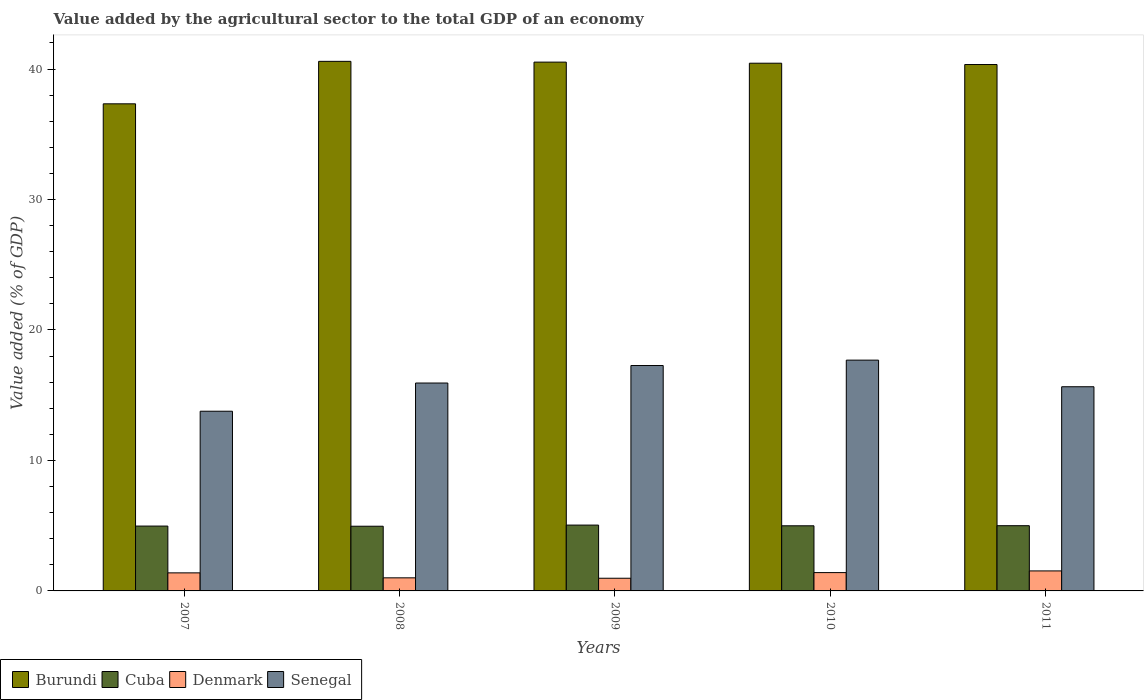How many groups of bars are there?
Give a very brief answer. 5. Are the number of bars per tick equal to the number of legend labels?
Ensure brevity in your answer.  Yes. How many bars are there on the 5th tick from the left?
Your response must be concise. 4. How many bars are there on the 3rd tick from the right?
Your response must be concise. 4. In how many cases, is the number of bars for a given year not equal to the number of legend labels?
Keep it short and to the point. 0. What is the value added by the agricultural sector to the total GDP in Denmark in 2010?
Your answer should be very brief. 1.4. Across all years, what is the maximum value added by the agricultural sector to the total GDP in Senegal?
Give a very brief answer. 17.69. Across all years, what is the minimum value added by the agricultural sector to the total GDP in Denmark?
Provide a short and direct response. 0.97. In which year was the value added by the agricultural sector to the total GDP in Burundi maximum?
Offer a terse response. 2008. What is the total value added by the agricultural sector to the total GDP in Cuba in the graph?
Your response must be concise. 24.97. What is the difference between the value added by the agricultural sector to the total GDP in Denmark in 2009 and that in 2011?
Your answer should be compact. -0.56. What is the difference between the value added by the agricultural sector to the total GDP in Burundi in 2007 and the value added by the agricultural sector to the total GDP in Denmark in 2011?
Provide a succinct answer. 35.8. What is the average value added by the agricultural sector to the total GDP in Senegal per year?
Give a very brief answer. 16.07. In the year 2010, what is the difference between the value added by the agricultural sector to the total GDP in Senegal and value added by the agricultural sector to the total GDP in Cuba?
Your answer should be very brief. 12.7. What is the ratio of the value added by the agricultural sector to the total GDP in Burundi in 2007 to that in 2011?
Your answer should be very brief. 0.93. Is the difference between the value added by the agricultural sector to the total GDP in Senegal in 2007 and 2011 greater than the difference between the value added by the agricultural sector to the total GDP in Cuba in 2007 and 2011?
Ensure brevity in your answer.  No. What is the difference between the highest and the second highest value added by the agricultural sector to the total GDP in Denmark?
Keep it short and to the point. 0.13. What is the difference between the highest and the lowest value added by the agricultural sector to the total GDP in Denmark?
Ensure brevity in your answer.  0.56. In how many years, is the value added by the agricultural sector to the total GDP in Cuba greater than the average value added by the agricultural sector to the total GDP in Cuba taken over all years?
Your answer should be very brief. 2. Is the sum of the value added by the agricultural sector to the total GDP in Burundi in 2009 and 2011 greater than the maximum value added by the agricultural sector to the total GDP in Denmark across all years?
Make the answer very short. Yes. Is it the case that in every year, the sum of the value added by the agricultural sector to the total GDP in Denmark and value added by the agricultural sector to the total GDP in Burundi is greater than the sum of value added by the agricultural sector to the total GDP in Cuba and value added by the agricultural sector to the total GDP in Senegal?
Offer a very short reply. Yes. What does the 2nd bar from the right in 2011 represents?
Offer a terse response. Denmark. Is it the case that in every year, the sum of the value added by the agricultural sector to the total GDP in Senegal and value added by the agricultural sector to the total GDP in Denmark is greater than the value added by the agricultural sector to the total GDP in Cuba?
Provide a succinct answer. Yes. How many years are there in the graph?
Make the answer very short. 5. What is the difference between two consecutive major ticks on the Y-axis?
Provide a succinct answer. 10. Does the graph contain any zero values?
Offer a very short reply. No. Does the graph contain grids?
Your answer should be very brief. No. How many legend labels are there?
Offer a very short reply. 4. What is the title of the graph?
Keep it short and to the point. Value added by the agricultural sector to the total GDP of an economy. What is the label or title of the Y-axis?
Offer a very short reply. Value added (% of GDP). What is the Value added (% of GDP) of Burundi in 2007?
Offer a terse response. 37.34. What is the Value added (% of GDP) in Cuba in 2007?
Keep it short and to the point. 4.97. What is the Value added (% of GDP) in Denmark in 2007?
Make the answer very short. 1.38. What is the Value added (% of GDP) in Senegal in 2007?
Give a very brief answer. 13.77. What is the Value added (% of GDP) in Burundi in 2008?
Give a very brief answer. 40.59. What is the Value added (% of GDP) of Cuba in 2008?
Your answer should be compact. 4.96. What is the Value added (% of GDP) in Denmark in 2008?
Ensure brevity in your answer.  1. What is the Value added (% of GDP) of Senegal in 2008?
Offer a terse response. 15.94. What is the Value added (% of GDP) of Burundi in 2009?
Offer a terse response. 40.53. What is the Value added (% of GDP) of Cuba in 2009?
Provide a short and direct response. 5.05. What is the Value added (% of GDP) in Denmark in 2009?
Make the answer very short. 0.97. What is the Value added (% of GDP) in Senegal in 2009?
Your answer should be compact. 17.28. What is the Value added (% of GDP) in Burundi in 2010?
Keep it short and to the point. 40.45. What is the Value added (% of GDP) in Cuba in 2010?
Provide a short and direct response. 4.99. What is the Value added (% of GDP) of Denmark in 2010?
Provide a succinct answer. 1.4. What is the Value added (% of GDP) of Senegal in 2010?
Ensure brevity in your answer.  17.69. What is the Value added (% of GDP) of Burundi in 2011?
Your answer should be very brief. 40.35. What is the Value added (% of GDP) in Cuba in 2011?
Provide a short and direct response. 5. What is the Value added (% of GDP) of Denmark in 2011?
Ensure brevity in your answer.  1.53. What is the Value added (% of GDP) in Senegal in 2011?
Offer a very short reply. 15.65. Across all years, what is the maximum Value added (% of GDP) of Burundi?
Your response must be concise. 40.59. Across all years, what is the maximum Value added (% of GDP) of Cuba?
Keep it short and to the point. 5.05. Across all years, what is the maximum Value added (% of GDP) in Denmark?
Your response must be concise. 1.53. Across all years, what is the maximum Value added (% of GDP) of Senegal?
Offer a very short reply. 17.69. Across all years, what is the minimum Value added (% of GDP) in Burundi?
Give a very brief answer. 37.34. Across all years, what is the minimum Value added (% of GDP) of Cuba?
Your response must be concise. 4.96. Across all years, what is the minimum Value added (% of GDP) in Denmark?
Keep it short and to the point. 0.97. Across all years, what is the minimum Value added (% of GDP) in Senegal?
Make the answer very short. 13.77. What is the total Value added (% of GDP) of Burundi in the graph?
Make the answer very short. 199.26. What is the total Value added (% of GDP) in Cuba in the graph?
Provide a succinct answer. 24.97. What is the total Value added (% of GDP) of Denmark in the graph?
Keep it short and to the point. 6.3. What is the total Value added (% of GDP) in Senegal in the graph?
Provide a succinct answer. 80.33. What is the difference between the Value added (% of GDP) in Burundi in 2007 and that in 2008?
Give a very brief answer. -3.25. What is the difference between the Value added (% of GDP) of Cuba in 2007 and that in 2008?
Your answer should be very brief. 0.01. What is the difference between the Value added (% of GDP) of Denmark in 2007 and that in 2008?
Your answer should be very brief. 0.38. What is the difference between the Value added (% of GDP) of Senegal in 2007 and that in 2008?
Your answer should be very brief. -2.16. What is the difference between the Value added (% of GDP) in Burundi in 2007 and that in 2009?
Provide a short and direct response. -3.2. What is the difference between the Value added (% of GDP) in Cuba in 2007 and that in 2009?
Make the answer very short. -0.08. What is the difference between the Value added (% of GDP) of Denmark in 2007 and that in 2009?
Provide a succinct answer. 0.41. What is the difference between the Value added (% of GDP) of Senegal in 2007 and that in 2009?
Your response must be concise. -3.5. What is the difference between the Value added (% of GDP) of Burundi in 2007 and that in 2010?
Your answer should be compact. -3.11. What is the difference between the Value added (% of GDP) of Cuba in 2007 and that in 2010?
Your response must be concise. -0.02. What is the difference between the Value added (% of GDP) of Denmark in 2007 and that in 2010?
Provide a short and direct response. -0.02. What is the difference between the Value added (% of GDP) in Senegal in 2007 and that in 2010?
Provide a short and direct response. -3.92. What is the difference between the Value added (% of GDP) in Burundi in 2007 and that in 2011?
Your answer should be very brief. -3.01. What is the difference between the Value added (% of GDP) of Cuba in 2007 and that in 2011?
Your response must be concise. -0.03. What is the difference between the Value added (% of GDP) in Denmark in 2007 and that in 2011?
Ensure brevity in your answer.  -0.15. What is the difference between the Value added (% of GDP) of Senegal in 2007 and that in 2011?
Keep it short and to the point. -1.88. What is the difference between the Value added (% of GDP) of Burundi in 2008 and that in 2009?
Provide a short and direct response. 0.06. What is the difference between the Value added (% of GDP) of Cuba in 2008 and that in 2009?
Your answer should be compact. -0.09. What is the difference between the Value added (% of GDP) in Denmark in 2008 and that in 2009?
Your answer should be very brief. 0.03. What is the difference between the Value added (% of GDP) of Senegal in 2008 and that in 2009?
Provide a short and direct response. -1.34. What is the difference between the Value added (% of GDP) of Burundi in 2008 and that in 2010?
Your answer should be compact. 0.14. What is the difference between the Value added (% of GDP) in Cuba in 2008 and that in 2010?
Ensure brevity in your answer.  -0.03. What is the difference between the Value added (% of GDP) in Denmark in 2008 and that in 2010?
Ensure brevity in your answer.  -0.4. What is the difference between the Value added (% of GDP) in Senegal in 2008 and that in 2010?
Ensure brevity in your answer.  -1.75. What is the difference between the Value added (% of GDP) of Burundi in 2008 and that in 2011?
Your answer should be very brief. 0.24. What is the difference between the Value added (% of GDP) of Cuba in 2008 and that in 2011?
Give a very brief answer. -0.04. What is the difference between the Value added (% of GDP) of Denmark in 2008 and that in 2011?
Give a very brief answer. -0.53. What is the difference between the Value added (% of GDP) of Senegal in 2008 and that in 2011?
Your answer should be very brief. 0.28. What is the difference between the Value added (% of GDP) of Burundi in 2009 and that in 2010?
Give a very brief answer. 0.08. What is the difference between the Value added (% of GDP) in Cuba in 2009 and that in 2010?
Keep it short and to the point. 0.05. What is the difference between the Value added (% of GDP) of Denmark in 2009 and that in 2010?
Your answer should be very brief. -0.43. What is the difference between the Value added (% of GDP) of Senegal in 2009 and that in 2010?
Make the answer very short. -0.41. What is the difference between the Value added (% of GDP) of Burundi in 2009 and that in 2011?
Provide a short and direct response. 0.18. What is the difference between the Value added (% of GDP) in Cuba in 2009 and that in 2011?
Your response must be concise. 0.05. What is the difference between the Value added (% of GDP) of Denmark in 2009 and that in 2011?
Your answer should be very brief. -0.56. What is the difference between the Value added (% of GDP) of Senegal in 2009 and that in 2011?
Your answer should be compact. 1.63. What is the difference between the Value added (% of GDP) in Burundi in 2010 and that in 2011?
Provide a succinct answer. 0.1. What is the difference between the Value added (% of GDP) of Cuba in 2010 and that in 2011?
Give a very brief answer. -0.01. What is the difference between the Value added (% of GDP) of Denmark in 2010 and that in 2011?
Keep it short and to the point. -0.13. What is the difference between the Value added (% of GDP) in Senegal in 2010 and that in 2011?
Offer a very short reply. 2.04. What is the difference between the Value added (% of GDP) of Burundi in 2007 and the Value added (% of GDP) of Cuba in 2008?
Make the answer very short. 32.38. What is the difference between the Value added (% of GDP) of Burundi in 2007 and the Value added (% of GDP) of Denmark in 2008?
Provide a succinct answer. 36.33. What is the difference between the Value added (% of GDP) in Burundi in 2007 and the Value added (% of GDP) in Senegal in 2008?
Offer a very short reply. 21.4. What is the difference between the Value added (% of GDP) of Cuba in 2007 and the Value added (% of GDP) of Denmark in 2008?
Give a very brief answer. 3.97. What is the difference between the Value added (% of GDP) in Cuba in 2007 and the Value added (% of GDP) in Senegal in 2008?
Your response must be concise. -10.96. What is the difference between the Value added (% of GDP) of Denmark in 2007 and the Value added (% of GDP) of Senegal in 2008?
Your response must be concise. -14.55. What is the difference between the Value added (% of GDP) of Burundi in 2007 and the Value added (% of GDP) of Cuba in 2009?
Give a very brief answer. 32.29. What is the difference between the Value added (% of GDP) in Burundi in 2007 and the Value added (% of GDP) in Denmark in 2009?
Provide a succinct answer. 36.36. What is the difference between the Value added (% of GDP) of Burundi in 2007 and the Value added (% of GDP) of Senegal in 2009?
Keep it short and to the point. 20.06. What is the difference between the Value added (% of GDP) in Cuba in 2007 and the Value added (% of GDP) in Denmark in 2009?
Offer a very short reply. 4. What is the difference between the Value added (% of GDP) in Cuba in 2007 and the Value added (% of GDP) in Senegal in 2009?
Give a very brief answer. -12.31. What is the difference between the Value added (% of GDP) of Denmark in 2007 and the Value added (% of GDP) of Senegal in 2009?
Provide a succinct answer. -15.89. What is the difference between the Value added (% of GDP) of Burundi in 2007 and the Value added (% of GDP) of Cuba in 2010?
Provide a short and direct response. 32.34. What is the difference between the Value added (% of GDP) in Burundi in 2007 and the Value added (% of GDP) in Denmark in 2010?
Provide a succinct answer. 35.93. What is the difference between the Value added (% of GDP) in Burundi in 2007 and the Value added (% of GDP) in Senegal in 2010?
Give a very brief answer. 19.65. What is the difference between the Value added (% of GDP) of Cuba in 2007 and the Value added (% of GDP) of Denmark in 2010?
Make the answer very short. 3.57. What is the difference between the Value added (% of GDP) in Cuba in 2007 and the Value added (% of GDP) in Senegal in 2010?
Offer a terse response. -12.72. What is the difference between the Value added (% of GDP) of Denmark in 2007 and the Value added (% of GDP) of Senegal in 2010?
Provide a succinct answer. -16.31. What is the difference between the Value added (% of GDP) in Burundi in 2007 and the Value added (% of GDP) in Cuba in 2011?
Make the answer very short. 32.34. What is the difference between the Value added (% of GDP) of Burundi in 2007 and the Value added (% of GDP) of Denmark in 2011?
Ensure brevity in your answer.  35.8. What is the difference between the Value added (% of GDP) of Burundi in 2007 and the Value added (% of GDP) of Senegal in 2011?
Make the answer very short. 21.69. What is the difference between the Value added (% of GDP) in Cuba in 2007 and the Value added (% of GDP) in Denmark in 2011?
Your answer should be very brief. 3.44. What is the difference between the Value added (% of GDP) of Cuba in 2007 and the Value added (% of GDP) of Senegal in 2011?
Offer a very short reply. -10.68. What is the difference between the Value added (% of GDP) in Denmark in 2007 and the Value added (% of GDP) in Senegal in 2011?
Ensure brevity in your answer.  -14.27. What is the difference between the Value added (% of GDP) in Burundi in 2008 and the Value added (% of GDP) in Cuba in 2009?
Your response must be concise. 35.54. What is the difference between the Value added (% of GDP) of Burundi in 2008 and the Value added (% of GDP) of Denmark in 2009?
Keep it short and to the point. 39.62. What is the difference between the Value added (% of GDP) in Burundi in 2008 and the Value added (% of GDP) in Senegal in 2009?
Your answer should be very brief. 23.31. What is the difference between the Value added (% of GDP) in Cuba in 2008 and the Value added (% of GDP) in Denmark in 2009?
Provide a succinct answer. 3.99. What is the difference between the Value added (% of GDP) of Cuba in 2008 and the Value added (% of GDP) of Senegal in 2009?
Provide a short and direct response. -12.32. What is the difference between the Value added (% of GDP) in Denmark in 2008 and the Value added (% of GDP) in Senegal in 2009?
Make the answer very short. -16.27. What is the difference between the Value added (% of GDP) in Burundi in 2008 and the Value added (% of GDP) in Cuba in 2010?
Make the answer very short. 35.6. What is the difference between the Value added (% of GDP) of Burundi in 2008 and the Value added (% of GDP) of Denmark in 2010?
Keep it short and to the point. 39.19. What is the difference between the Value added (% of GDP) of Burundi in 2008 and the Value added (% of GDP) of Senegal in 2010?
Your answer should be very brief. 22.9. What is the difference between the Value added (% of GDP) in Cuba in 2008 and the Value added (% of GDP) in Denmark in 2010?
Your response must be concise. 3.56. What is the difference between the Value added (% of GDP) of Cuba in 2008 and the Value added (% of GDP) of Senegal in 2010?
Make the answer very short. -12.73. What is the difference between the Value added (% of GDP) of Denmark in 2008 and the Value added (% of GDP) of Senegal in 2010?
Your response must be concise. -16.69. What is the difference between the Value added (% of GDP) in Burundi in 2008 and the Value added (% of GDP) in Cuba in 2011?
Your answer should be compact. 35.59. What is the difference between the Value added (% of GDP) in Burundi in 2008 and the Value added (% of GDP) in Denmark in 2011?
Give a very brief answer. 39.06. What is the difference between the Value added (% of GDP) of Burundi in 2008 and the Value added (% of GDP) of Senegal in 2011?
Give a very brief answer. 24.94. What is the difference between the Value added (% of GDP) in Cuba in 2008 and the Value added (% of GDP) in Denmark in 2011?
Your answer should be compact. 3.43. What is the difference between the Value added (% of GDP) in Cuba in 2008 and the Value added (% of GDP) in Senegal in 2011?
Your answer should be compact. -10.69. What is the difference between the Value added (% of GDP) in Denmark in 2008 and the Value added (% of GDP) in Senegal in 2011?
Make the answer very short. -14.65. What is the difference between the Value added (% of GDP) in Burundi in 2009 and the Value added (% of GDP) in Cuba in 2010?
Your response must be concise. 35.54. What is the difference between the Value added (% of GDP) in Burundi in 2009 and the Value added (% of GDP) in Denmark in 2010?
Offer a terse response. 39.13. What is the difference between the Value added (% of GDP) of Burundi in 2009 and the Value added (% of GDP) of Senegal in 2010?
Offer a terse response. 22.84. What is the difference between the Value added (% of GDP) in Cuba in 2009 and the Value added (% of GDP) in Denmark in 2010?
Offer a terse response. 3.64. What is the difference between the Value added (% of GDP) of Cuba in 2009 and the Value added (% of GDP) of Senegal in 2010?
Ensure brevity in your answer.  -12.64. What is the difference between the Value added (% of GDP) in Denmark in 2009 and the Value added (% of GDP) in Senegal in 2010?
Your response must be concise. -16.72. What is the difference between the Value added (% of GDP) in Burundi in 2009 and the Value added (% of GDP) in Cuba in 2011?
Your answer should be very brief. 35.53. What is the difference between the Value added (% of GDP) of Burundi in 2009 and the Value added (% of GDP) of Denmark in 2011?
Keep it short and to the point. 39. What is the difference between the Value added (% of GDP) in Burundi in 2009 and the Value added (% of GDP) in Senegal in 2011?
Your answer should be very brief. 24.88. What is the difference between the Value added (% of GDP) of Cuba in 2009 and the Value added (% of GDP) of Denmark in 2011?
Ensure brevity in your answer.  3.51. What is the difference between the Value added (% of GDP) of Cuba in 2009 and the Value added (% of GDP) of Senegal in 2011?
Provide a short and direct response. -10.6. What is the difference between the Value added (% of GDP) in Denmark in 2009 and the Value added (% of GDP) in Senegal in 2011?
Your answer should be compact. -14.68. What is the difference between the Value added (% of GDP) of Burundi in 2010 and the Value added (% of GDP) of Cuba in 2011?
Your response must be concise. 35.45. What is the difference between the Value added (% of GDP) of Burundi in 2010 and the Value added (% of GDP) of Denmark in 2011?
Keep it short and to the point. 38.91. What is the difference between the Value added (% of GDP) in Burundi in 2010 and the Value added (% of GDP) in Senegal in 2011?
Your answer should be very brief. 24.8. What is the difference between the Value added (% of GDP) of Cuba in 2010 and the Value added (% of GDP) of Denmark in 2011?
Make the answer very short. 3.46. What is the difference between the Value added (% of GDP) in Cuba in 2010 and the Value added (% of GDP) in Senegal in 2011?
Your response must be concise. -10.66. What is the difference between the Value added (% of GDP) in Denmark in 2010 and the Value added (% of GDP) in Senegal in 2011?
Your response must be concise. -14.25. What is the average Value added (% of GDP) of Burundi per year?
Provide a succinct answer. 39.85. What is the average Value added (% of GDP) in Cuba per year?
Make the answer very short. 4.99. What is the average Value added (% of GDP) of Denmark per year?
Your answer should be very brief. 1.26. What is the average Value added (% of GDP) in Senegal per year?
Keep it short and to the point. 16.07. In the year 2007, what is the difference between the Value added (% of GDP) of Burundi and Value added (% of GDP) of Cuba?
Provide a short and direct response. 32.37. In the year 2007, what is the difference between the Value added (% of GDP) in Burundi and Value added (% of GDP) in Denmark?
Provide a short and direct response. 35.95. In the year 2007, what is the difference between the Value added (% of GDP) of Burundi and Value added (% of GDP) of Senegal?
Keep it short and to the point. 23.56. In the year 2007, what is the difference between the Value added (% of GDP) in Cuba and Value added (% of GDP) in Denmark?
Offer a terse response. 3.59. In the year 2007, what is the difference between the Value added (% of GDP) of Cuba and Value added (% of GDP) of Senegal?
Your response must be concise. -8.8. In the year 2007, what is the difference between the Value added (% of GDP) in Denmark and Value added (% of GDP) in Senegal?
Provide a short and direct response. -12.39. In the year 2008, what is the difference between the Value added (% of GDP) in Burundi and Value added (% of GDP) in Cuba?
Provide a short and direct response. 35.63. In the year 2008, what is the difference between the Value added (% of GDP) in Burundi and Value added (% of GDP) in Denmark?
Keep it short and to the point. 39.59. In the year 2008, what is the difference between the Value added (% of GDP) in Burundi and Value added (% of GDP) in Senegal?
Make the answer very short. 24.66. In the year 2008, what is the difference between the Value added (% of GDP) of Cuba and Value added (% of GDP) of Denmark?
Your answer should be compact. 3.96. In the year 2008, what is the difference between the Value added (% of GDP) in Cuba and Value added (% of GDP) in Senegal?
Make the answer very short. -10.98. In the year 2008, what is the difference between the Value added (% of GDP) in Denmark and Value added (% of GDP) in Senegal?
Your answer should be compact. -14.93. In the year 2009, what is the difference between the Value added (% of GDP) in Burundi and Value added (% of GDP) in Cuba?
Your response must be concise. 35.49. In the year 2009, what is the difference between the Value added (% of GDP) in Burundi and Value added (% of GDP) in Denmark?
Ensure brevity in your answer.  39.56. In the year 2009, what is the difference between the Value added (% of GDP) in Burundi and Value added (% of GDP) in Senegal?
Offer a terse response. 23.26. In the year 2009, what is the difference between the Value added (% of GDP) of Cuba and Value added (% of GDP) of Denmark?
Your answer should be very brief. 4.07. In the year 2009, what is the difference between the Value added (% of GDP) of Cuba and Value added (% of GDP) of Senegal?
Make the answer very short. -12.23. In the year 2009, what is the difference between the Value added (% of GDP) of Denmark and Value added (% of GDP) of Senegal?
Make the answer very short. -16.3. In the year 2010, what is the difference between the Value added (% of GDP) in Burundi and Value added (% of GDP) in Cuba?
Provide a short and direct response. 35.46. In the year 2010, what is the difference between the Value added (% of GDP) in Burundi and Value added (% of GDP) in Denmark?
Provide a succinct answer. 39.04. In the year 2010, what is the difference between the Value added (% of GDP) in Burundi and Value added (% of GDP) in Senegal?
Make the answer very short. 22.76. In the year 2010, what is the difference between the Value added (% of GDP) of Cuba and Value added (% of GDP) of Denmark?
Give a very brief answer. 3.59. In the year 2010, what is the difference between the Value added (% of GDP) of Cuba and Value added (% of GDP) of Senegal?
Offer a very short reply. -12.7. In the year 2010, what is the difference between the Value added (% of GDP) in Denmark and Value added (% of GDP) in Senegal?
Give a very brief answer. -16.29. In the year 2011, what is the difference between the Value added (% of GDP) in Burundi and Value added (% of GDP) in Cuba?
Your answer should be compact. 35.35. In the year 2011, what is the difference between the Value added (% of GDP) in Burundi and Value added (% of GDP) in Denmark?
Ensure brevity in your answer.  38.81. In the year 2011, what is the difference between the Value added (% of GDP) in Burundi and Value added (% of GDP) in Senegal?
Keep it short and to the point. 24.7. In the year 2011, what is the difference between the Value added (% of GDP) of Cuba and Value added (% of GDP) of Denmark?
Provide a succinct answer. 3.47. In the year 2011, what is the difference between the Value added (% of GDP) in Cuba and Value added (% of GDP) in Senegal?
Make the answer very short. -10.65. In the year 2011, what is the difference between the Value added (% of GDP) in Denmark and Value added (% of GDP) in Senegal?
Provide a succinct answer. -14.12. What is the ratio of the Value added (% of GDP) of Burundi in 2007 to that in 2008?
Your answer should be compact. 0.92. What is the ratio of the Value added (% of GDP) in Cuba in 2007 to that in 2008?
Your answer should be compact. 1. What is the ratio of the Value added (% of GDP) in Denmark in 2007 to that in 2008?
Make the answer very short. 1.38. What is the ratio of the Value added (% of GDP) in Senegal in 2007 to that in 2008?
Ensure brevity in your answer.  0.86. What is the ratio of the Value added (% of GDP) in Burundi in 2007 to that in 2009?
Your response must be concise. 0.92. What is the ratio of the Value added (% of GDP) of Cuba in 2007 to that in 2009?
Your answer should be compact. 0.98. What is the ratio of the Value added (% of GDP) in Denmark in 2007 to that in 2009?
Ensure brevity in your answer.  1.42. What is the ratio of the Value added (% of GDP) of Senegal in 2007 to that in 2009?
Give a very brief answer. 0.8. What is the ratio of the Value added (% of GDP) in Denmark in 2007 to that in 2010?
Provide a succinct answer. 0.99. What is the ratio of the Value added (% of GDP) in Senegal in 2007 to that in 2010?
Provide a succinct answer. 0.78. What is the ratio of the Value added (% of GDP) in Burundi in 2007 to that in 2011?
Offer a terse response. 0.93. What is the ratio of the Value added (% of GDP) in Denmark in 2007 to that in 2011?
Keep it short and to the point. 0.9. What is the ratio of the Value added (% of GDP) of Senegal in 2007 to that in 2011?
Offer a terse response. 0.88. What is the ratio of the Value added (% of GDP) of Burundi in 2008 to that in 2009?
Your answer should be compact. 1. What is the ratio of the Value added (% of GDP) in Cuba in 2008 to that in 2009?
Provide a succinct answer. 0.98. What is the ratio of the Value added (% of GDP) in Denmark in 2008 to that in 2009?
Ensure brevity in your answer.  1.03. What is the ratio of the Value added (% of GDP) of Senegal in 2008 to that in 2009?
Ensure brevity in your answer.  0.92. What is the ratio of the Value added (% of GDP) in Burundi in 2008 to that in 2010?
Your answer should be compact. 1. What is the ratio of the Value added (% of GDP) of Cuba in 2008 to that in 2010?
Your answer should be compact. 0.99. What is the ratio of the Value added (% of GDP) of Denmark in 2008 to that in 2010?
Your answer should be compact. 0.71. What is the ratio of the Value added (% of GDP) in Senegal in 2008 to that in 2010?
Provide a short and direct response. 0.9. What is the ratio of the Value added (% of GDP) of Denmark in 2008 to that in 2011?
Ensure brevity in your answer.  0.65. What is the ratio of the Value added (% of GDP) in Senegal in 2008 to that in 2011?
Provide a succinct answer. 1.02. What is the ratio of the Value added (% of GDP) of Burundi in 2009 to that in 2010?
Ensure brevity in your answer.  1. What is the ratio of the Value added (% of GDP) in Cuba in 2009 to that in 2010?
Offer a terse response. 1.01. What is the ratio of the Value added (% of GDP) in Denmark in 2009 to that in 2010?
Your answer should be compact. 0.69. What is the ratio of the Value added (% of GDP) of Senegal in 2009 to that in 2010?
Your response must be concise. 0.98. What is the ratio of the Value added (% of GDP) of Cuba in 2009 to that in 2011?
Your response must be concise. 1.01. What is the ratio of the Value added (% of GDP) in Denmark in 2009 to that in 2011?
Provide a succinct answer. 0.63. What is the ratio of the Value added (% of GDP) in Senegal in 2009 to that in 2011?
Provide a succinct answer. 1.1. What is the ratio of the Value added (% of GDP) in Denmark in 2010 to that in 2011?
Your answer should be compact. 0.92. What is the ratio of the Value added (% of GDP) in Senegal in 2010 to that in 2011?
Provide a succinct answer. 1.13. What is the difference between the highest and the second highest Value added (% of GDP) of Burundi?
Make the answer very short. 0.06. What is the difference between the highest and the second highest Value added (% of GDP) of Cuba?
Provide a succinct answer. 0.05. What is the difference between the highest and the second highest Value added (% of GDP) in Denmark?
Provide a short and direct response. 0.13. What is the difference between the highest and the second highest Value added (% of GDP) in Senegal?
Provide a short and direct response. 0.41. What is the difference between the highest and the lowest Value added (% of GDP) in Burundi?
Your answer should be compact. 3.25. What is the difference between the highest and the lowest Value added (% of GDP) of Cuba?
Provide a short and direct response. 0.09. What is the difference between the highest and the lowest Value added (% of GDP) of Denmark?
Provide a succinct answer. 0.56. What is the difference between the highest and the lowest Value added (% of GDP) in Senegal?
Give a very brief answer. 3.92. 